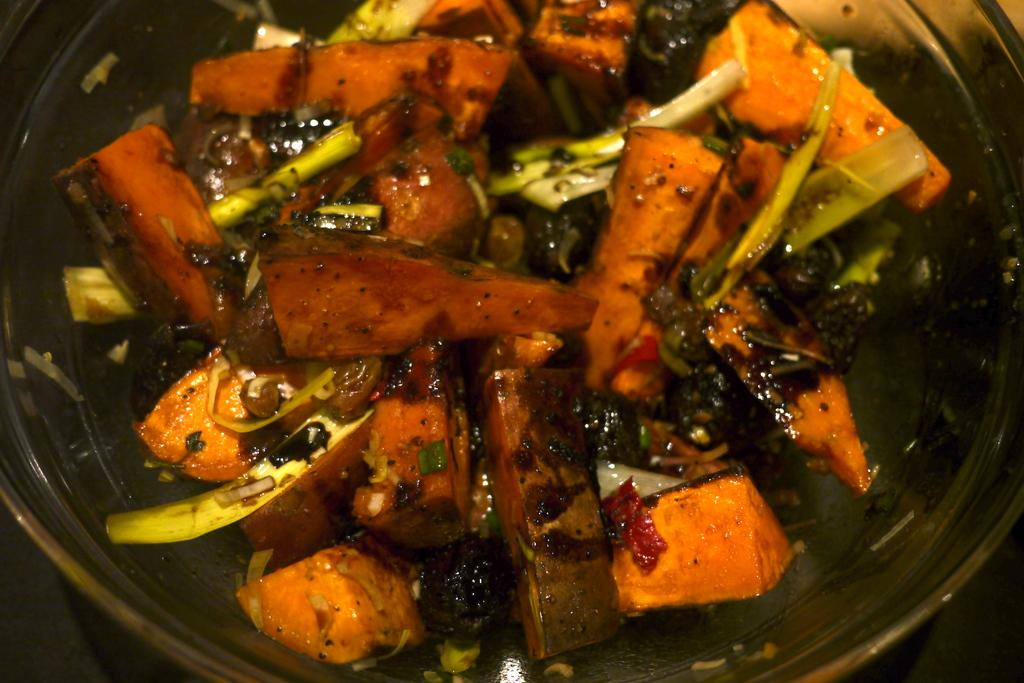What is in the bowl that is visible in the image? There is food in the bowl in the image. What colors can be seen in the food? The food has green and orange colors. What is the color of the surface the bowl is placed on? The surface the bowl is on is black. How does the snow affect the food in the image? There is no snow present in the image, so it does not affect the food. 